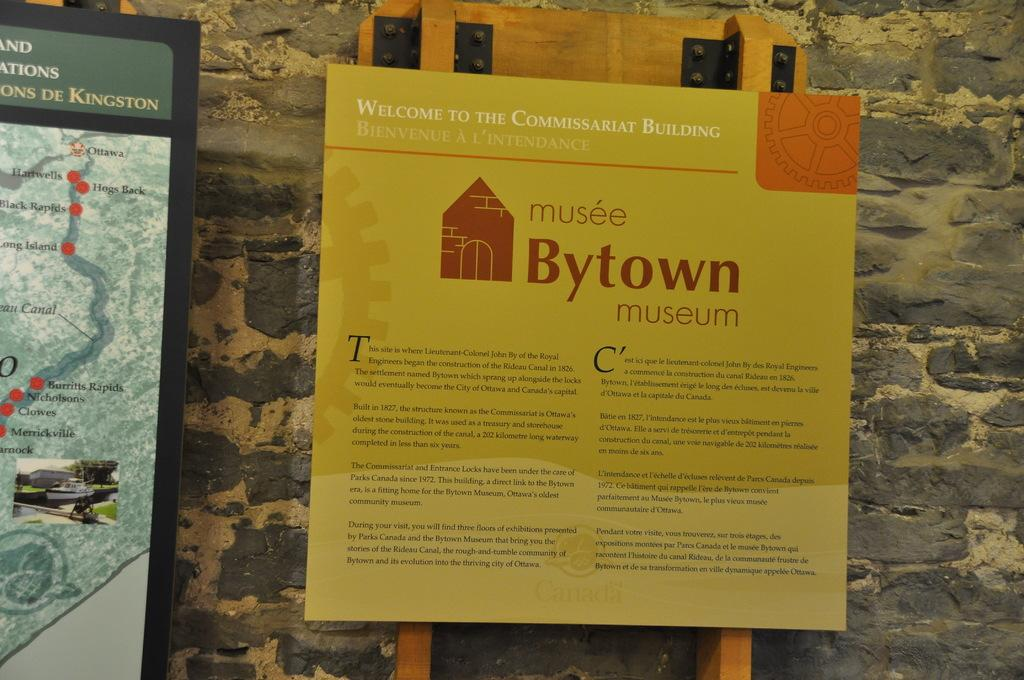<image>
Share a concise interpretation of the image provided. A sign in front of a stone wall has "Bytown museum" on it. 